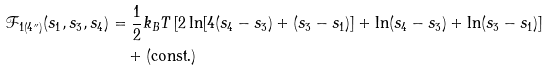Convert formula to latex. <formula><loc_0><loc_0><loc_500><loc_500>\mathcal { F } _ { 1 ( 4 ^ { \prime \prime } ) } ( s _ { 1 } , s _ { 3 } , s _ { 4 } ) & = \frac { 1 } { 2 } k _ { B } T \left [ 2 \ln [ 4 ( s _ { 4 } - s _ { 3 } ) + ( s _ { 3 } - s _ { 1 } ) ] + \ln ( s _ { 4 } - s _ { 3 } ) + \ln ( s _ { 3 } - s _ { 1 } ) \right ] \\ & \quad + \text {(const.)}</formula> 